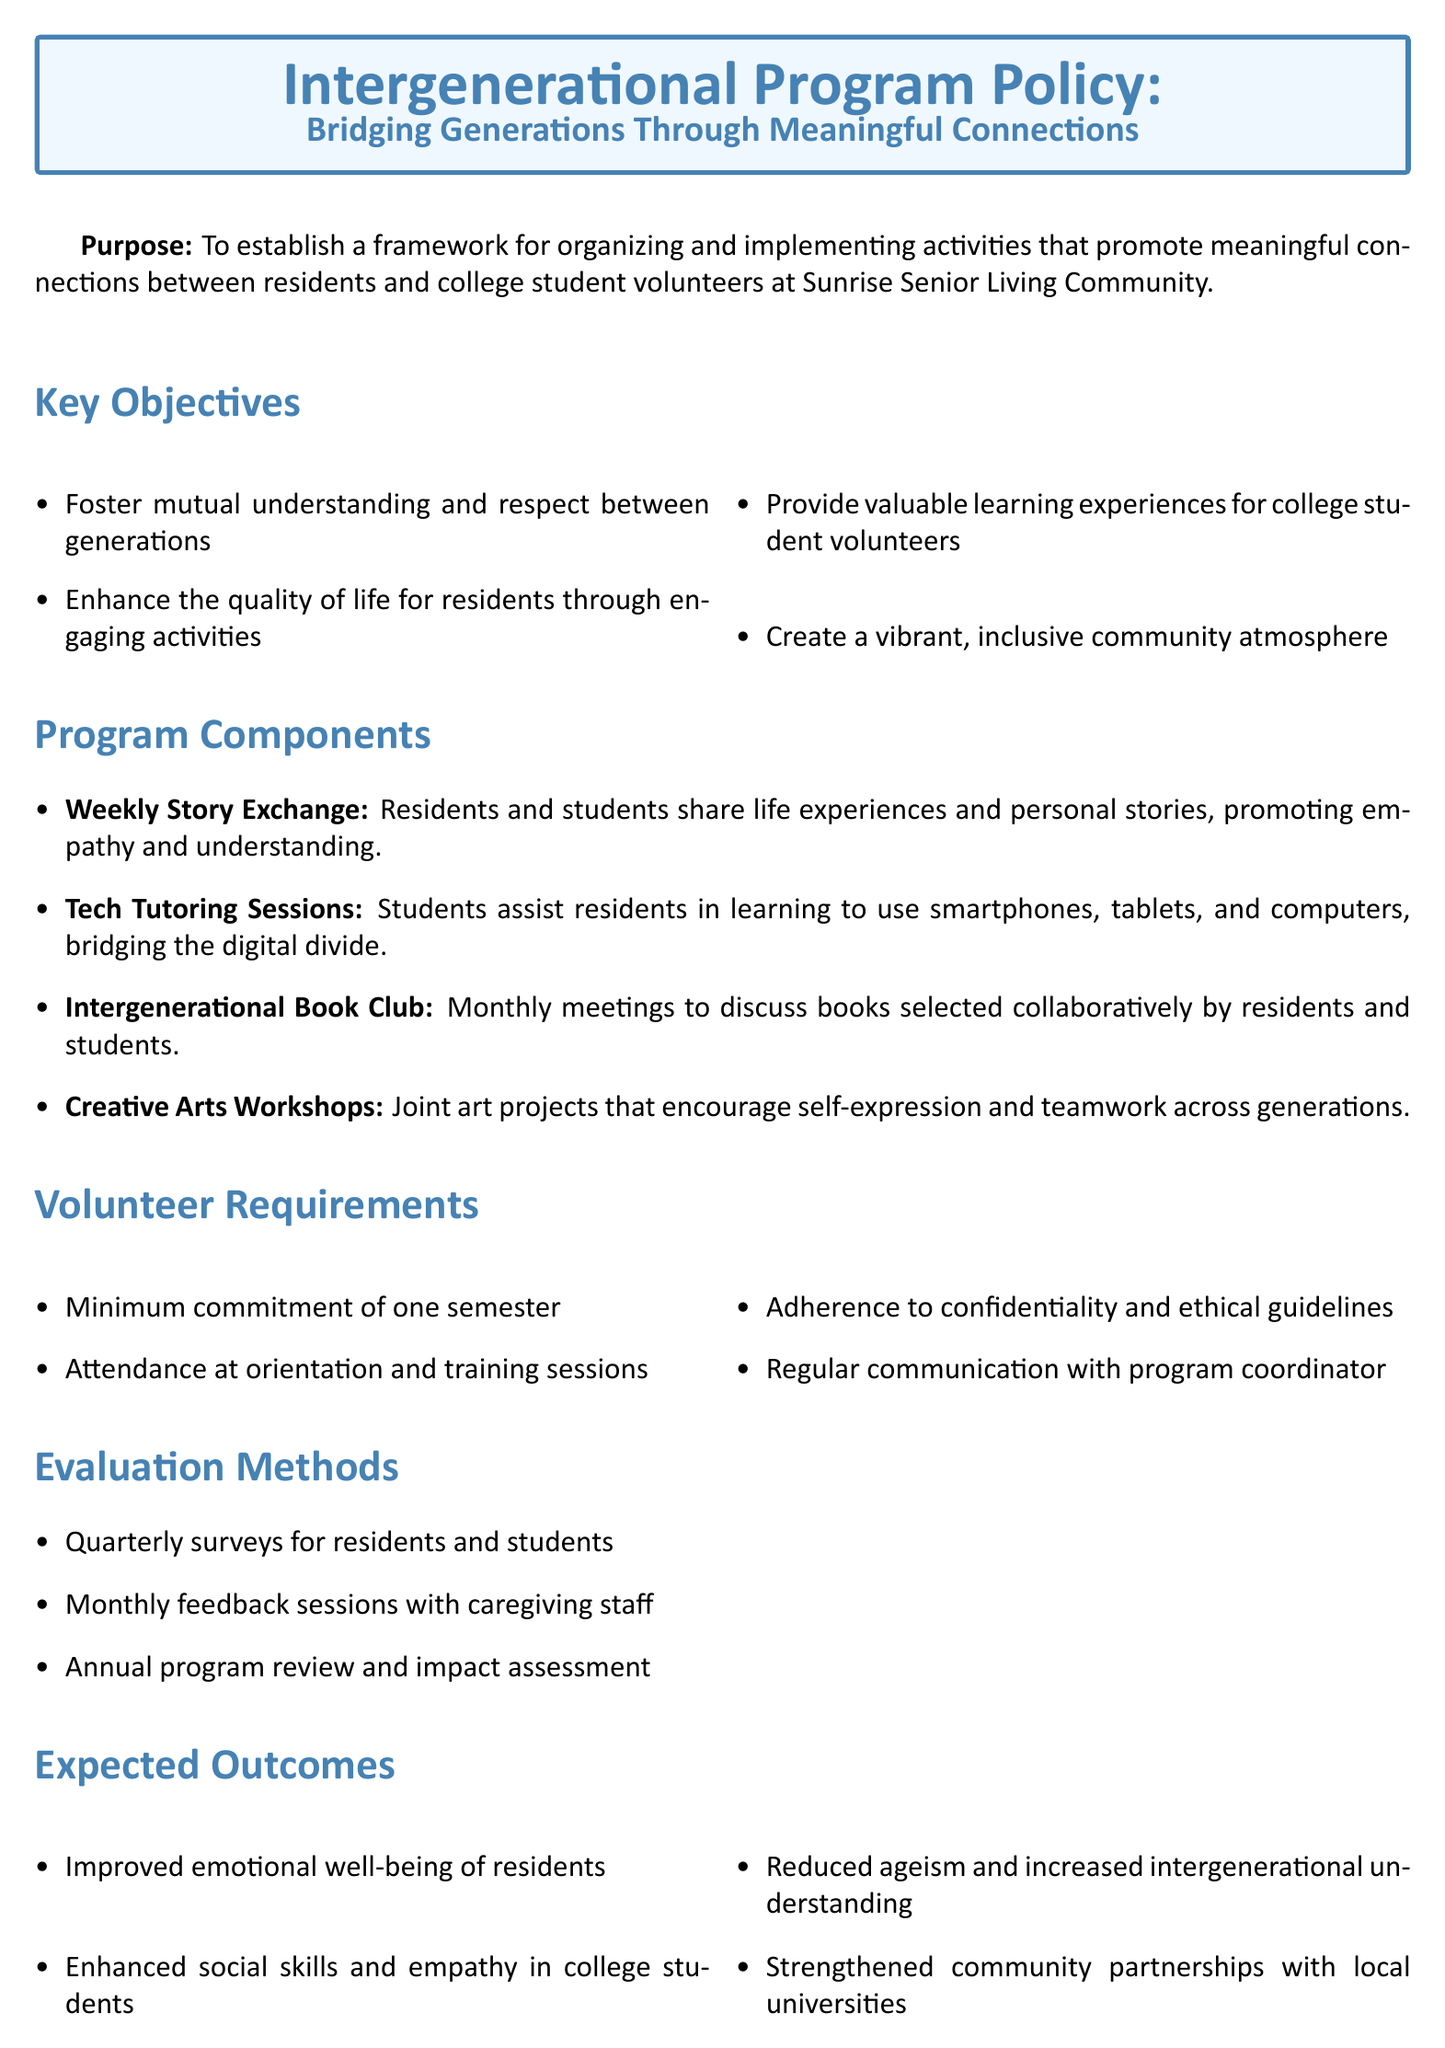what is the purpose of the policy? The purpose is to establish a framework for organizing and implementing activities that promote meaningful connections between residents and college student volunteers.
Answer: To establish a framework for organizing and implementing activities that promote meaningful connections between residents and college student volunteers how many program components are listed? The number of program components is found in the section detailing the components of the program.
Answer: Four what is one key objective of the program? A key objective can be identified from the list of objectives provided in the document.
Answer: Foster mutual understanding and respect between generations what is required from volunteers in terms of time commitment? The time commitment required from volunteers is stated under the volunteer requirements section.
Answer: Minimum commitment of one semester how often will evaluations take place? The frequency of evaluations is indicated in the evaluation methods section.
Answer: Quarterly which activity involves sharing life experiences? The specific activity related to sharing life experiences is detailed in the program components section.
Answer: Weekly Story Exchange what are residents expected to gain from the program? The expected outcomes for residents are outlined in the document, specifying their emotional and social benefits.
Answer: Improved emotional well-being of residents what document section mentions the caregiver's role? The section that describes the caregiver's role is labeled specifically.
Answer: Caregiver Role what is the term used for the collaborative book discussions? The specific term for the book discussions is directly stated in the program components.
Answer: Intergenerational Book Club 